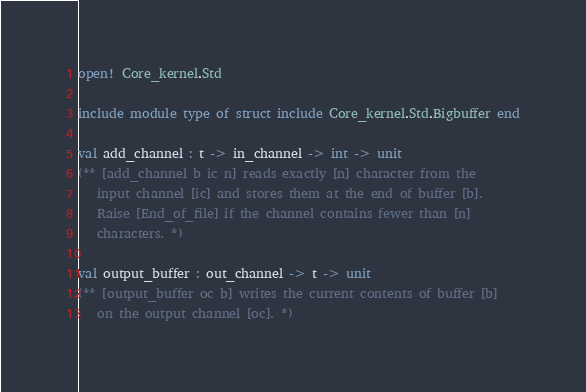Convert code to text. <code><loc_0><loc_0><loc_500><loc_500><_OCaml_>open! Core_kernel.Std

include module type of struct include Core_kernel.Std.Bigbuffer end

val add_channel : t -> in_channel -> int -> unit
(** [add_channel b ic n] reads exactly [n] character from the
   input channel [ic] and stores them at the end of buffer [b].
   Raise [End_of_file] if the channel contains fewer than [n]
   characters. *)

val output_buffer : out_channel -> t -> unit
(** [output_buffer oc b] writes the current contents of buffer [b]
   on the output channel [oc]. *)
</code> 